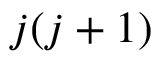<formula> <loc_0><loc_0><loc_500><loc_500>j ( j + 1 )</formula> 